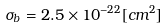<formula> <loc_0><loc_0><loc_500><loc_500>\sigma _ { b } = 2 . 5 \times 1 0 ^ { - 2 2 } [ c m ^ { 2 } ]</formula> 